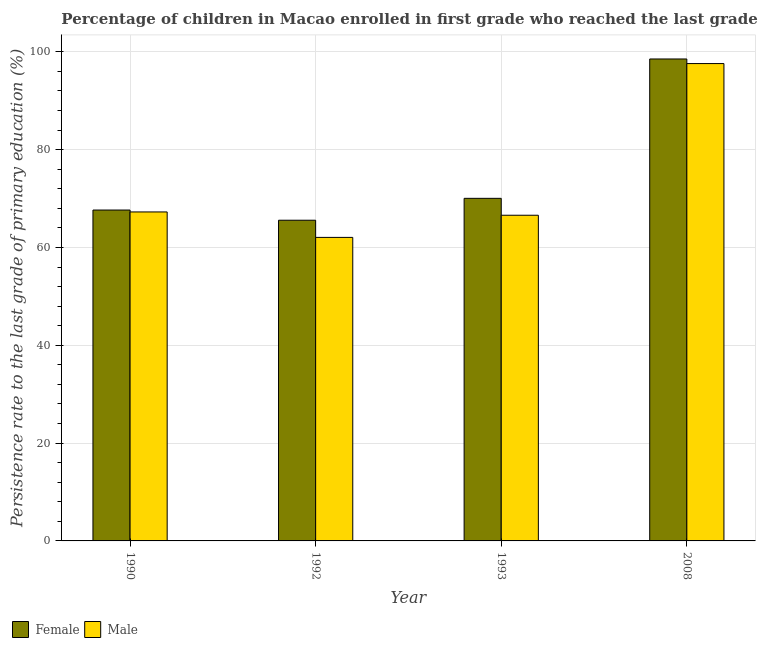How many different coloured bars are there?
Provide a short and direct response. 2. Are the number of bars on each tick of the X-axis equal?
Your answer should be compact. Yes. How many bars are there on the 4th tick from the right?
Offer a very short reply. 2. In how many cases, is the number of bars for a given year not equal to the number of legend labels?
Give a very brief answer. 0. What is the persistence rate of male students in 1993?
Provide a succinct answer. 66.59. Across all years, what is the maximum persistence rate of female students?
Your answer should be very brief. 98.54. Across all years, what is the minimum persistence rate of female students?
Give a very brief answer. 65.57. In which year was the persistence rate of female students minimum?
Ensure brevity in your answer.  1992. What is the total persistence rate of male students in the graph?
Provide a short and direct response. 293.52. What is the difference between the persistence rate of male students in 1990 and that in 1993?
Your answer should be compact. 0.68. What is the difference between the persistence rate of female students in 1992 and the persistence rate of male students in 1993?
Your answer should be very brief. -4.48. What is the average persistence rate of male students per year?
Make the answer very short. 73.38. What is the ratio of the persistence rate of female students in 1993 to that in 2008?
Offer a very short reply. 0.71. Is the persistence rate of female students in 1990 less than that in 1993?
Offer a terse response. Yes. Is the difference between the persistence rate of female students in 1993 and 2008 greater than the difference between the persistence rate of male students in 1993 and 2008?
Ensure brevity in your answer.  No. What is the difference between the highest and the second highest persistence rate of female students?
Your response must be concise. 28.49. What is the difference between the highest and the lowest persistence rate of male students?
Give a very brief answer. 35.54. What does the 1st bar from the left in 2008 represents?
Your answer should be compact. Female. How many bars are there?
Provide a short and direct response. 8. Are all the bars in the graph horizontal?
Offer a terse response. No. What is the difference between two consecutive major ticks on the Y-axis?
Give a very brief answer. 20. Are the values on the major ticks of Y-axis written in scientific E-notation?
Provide a short and direct response. No. Does the graph contain grids?
Make the answer very short. Yes. Where does the legend appear in the graph?
Ensure brevity in your answer.  Bottom left. How many legend labels are there?
Keep it short and to the point. 2. What is the title of the graph?
Ensure brevity in your answer.  Percentage of children in Macao enrolled in first grade who reached the last grade of primary education. Does "Total Population" appear as one of the legend labels in the graph?
Provide a short and direct response. No. What is the label or title of the X-axis?
Provide a succinct answer. Year. What is the label or title of the Y-axis?
Offer a very short reply. Persistence rate to the last grade of primary education (%). What is the Persistence rate to the last grade of primary education (%) of Female in 1990?
Your answer should be compact. 67.66. What is the Persistence rate to the last grade of primary education (%) in Male in 1990?
Your answer should be compact. 67.27. What is the Persistence rate to the last grade of primary education (%) of Female in 1992?
Offer a terse response. 65.57. What is the Persistence rate to the last grade of primary education (%) of Male in 1992?
Provide a short and direct response. 62.06. What is the Persistence rate to the last grade of primary education (%) in Female in 1993?
Make the answer very short. 70.05. What is the Persistence rate to the last grade of primary education (%) of Male in 1993?
Provide a short and direct response. 66.59. What is the Persistence rate to the last grade of primary education (%) in Female in 2008?
Your answer should be very brief. 98.54. What is the Persistence rate to the last grade of primary education (%) of Male in 2008?
Give a very brief answer. 97.6. Across all years, what is the maximum Persistence rate to the last grade of primary education (%) of Female?
Your response must be concise. 98.54. Across all years, what is the maximum Persistence rate to the last grade of primary education (%) in Male?
Offer a very short reply. 97.6. Across all years, what is the minimum Persistence rate to the last grade of primary education (%) in Female?
Ensure brevity in your answer.  65.57. Across all years, what is the minimum Persistence rate to the last grade of primary education (%) of Male?
Offer a terse response. 62.06. What is the total Persistence rate to the last grade of primary education (%) in Female in the graph?
Provide a short and direct response. 301.82. What is the total Persistence rate to the last grade of primary education (%) of Male in the graph?
Your answer should be compact. 293.52. What is the difference between the Persistence rate to the last grade of primary education (%) in Female in 1990 and that in 1992?
Your answer should be very brief. 2.08. What is the difference between the Persistence rate to the last grade of primary education (%) of Male in 1990 and that in 1992?
Provide a short and direct response. 5.2. What is the difference between the Persistence rate to the last grade of primary education (%) in Female in 1990 and that in 1993?
Your answer should be compact. -2.39. What is the difference between the Persistence rate to the last grade of primary education (%) of Male in 1990 and that in 1993?
Offer a terse response. 0.68. What is the difference between the Persistence rate to the last grade of primary education (%) in Female in 1990 and that in 2008?
Your answer should be very brief. -30.89. What is the difference between the Persistence rate to the last grade of primary education (%) in Male in 1990 and that in 2008?
Provide a succinct answer. -30.34. What is the difference between the Persistence rate to the last grade of primary education (%) in Female in 1992 and that in 1993?
Provide a succinct answer. -4.48. What is the difference between the Persistence rate to the last grade of primary education (%) in Male in 1992 and that in 1993?
Make the answer very short. -4.53. What is the difference between the Persistence rate to the last grade of primary education (%) of Female in 1992 and that in 2008?
Offer a very short reply. -32.97. What is the difference between the Persistence rate to the last grade of primary education (%) of Male in 1992 and that in 2008?
Make the answer very short. -35.54. What is the difference between the Persistence rate to the last grade of primary education (%) in Female in 1993 and that in 2008?
Provide a succinct answer. -28.49. What is the difference between the Persistence rate to the last grade of primary education (%) of Male in 1993 and that in 2008?
Offer a very short reply. -31.01. What is the difference between the Persistence rate to the last grade of primary education (%) in Female in 1990 and the Persistence rate to the last grade of primary education (%) in Male in 1992?
Provide a succinct answer. 5.59. What is the difference between the Persistence rate to the last grade of primary education (%) of Female in 1990 and the Persistence rate to the last grade of primary education (%) of Male in 1993?
Keep it short and to the point. 1.07. What is the difference between the Persistence rate to the last grade of primary education (%) in Female in 1990 and the Persistence rate to the last grade of primary education (%) in Male in 2008?
Your answer should be compact. -29.95. What is the difference between the Persistence rate to the last grade of primary education (%) of Female in 1992 and the Persistence rate to the last grade of primary education (%) of Male in 1993?
Make the answer very short. -1.02. What is the difference between the Persistence rate to the last grade of primary education (%) of Female in 1992 and the Persistence rate to the last grade of primary education (%) of Male in 2008?
Make the answer very short. -32.03. What is the difference between the Persistence rate to the last grade of primary education (%) of Female in 1993 and the Persistence rate to the last grade of primary education (%) of Male in 2008?
Offer a terse response. -27.55. What is the average Persistence rate to the last grade of primary education (%) of Female per year?
Offer a terse response. 75.46. What is the average Persistence rate to the last grade of primary education (%) of Male per year?
Make the answer very short. 73.38. In the year 1990, what is the difference between the Persistence rate to the last grade of primary education (%) of Female and Persistence rate to the last grade of primary education (%) of Male?
Provide a succinct answer. 0.39. In the year 1992, what is the difference between the Persistence rate to the last grade of primary education (%) of Female and Persistence rate to the last grade of primary education (%) of Male?
Your answer should be very brief. 3.51. In the year 1993, what is the difference between the Persistence rate to the last grade of primary education (%) of Female and Persistence rate to the last grade of primary education (%) of Male?
Your answer should be compact. 3.46. In the year 2008, what is the difference between the Persistence rate to the last grade of primary education (%) of Female and Persistence rate to the last grade of primary education (%) of Male?
Offer a very short reply. 0.94. What is the ratio of the Persistence rate to the last grade of primary education (%) in Female in 1990 to that in 1992?
Make the answer very short. 1.03. What is the ratio of the Persistence rate to the last grade of primary education (%) of Male in 1990 to that in 1992?
Ensure brevity in your answer.  1.08. What is the ratio of the Persistence rate to the last grade of primary education (%) in Female in 1990 to that in 1993?
Provide a succinct answer. 0.97. What is the ratio of the Persistence rate to the last grade of primary education (%) in Male in 1990 to that in 1993?
Ensure brevity in your answer.  1.01. What is the ratio of the Persistence rate to the last grade of primary education (%) of Female in 1990 to that in 2008?
Your response must be concise. 0.69. What is the ratio of the Persistence rate to the last grade of primary education (%) in Male in 1990 to that in 2008?
Offer a very short reply. 0.69. What is the ratio of the Persistence rate to the last grade of primary education (%) in Female in 1992 to that in 1993?
Your answer should be compact. 0.94. What is the ratio of the Persistence rate to the last grade of primary education (%) in Male in 1992 to that in 1993?
Your answer should be compact. 0.93. What is the ratio of the Persistence rate to the last grade of primary education (%) in Female in 1992 to that in 2008?
Provide a short and direct response. 0.67. What is the ratio of the Persistence rate to the last grade of primary education (%) of Male in 1992 to that in 2008?
Offer a very short reply. 0.64. What is the ratio of the Persistence rate to the last grade of primary education (%) in Female in 1993 to that in 2008?
Your answer should be very brief. 0.71. What is the ratio of the Persistence rate to the last grade of primary education (%) in Male in 1993 to that in 2008?
Provide a short and direct response. 0.68. What is the difference between the highest and the second highest Persistence rate to the last grade of primary education (%) in Female?
Keep it short and to the point. 28.49. What is the difference between the highest and the second highest Persistence rate to the last grade of primary education (%) in Male?
Provide a short and direct response. 30.34. What is the difference between the highest and the lowest Persistence rate to the last grade of primary education (%) of Female?
Keep it short and to the point. 32.97. What is the difference between the highest and the lowest Persistence rate to the last grade of primary education (%) in Male?
Keep it short and to the point. 35.54. 